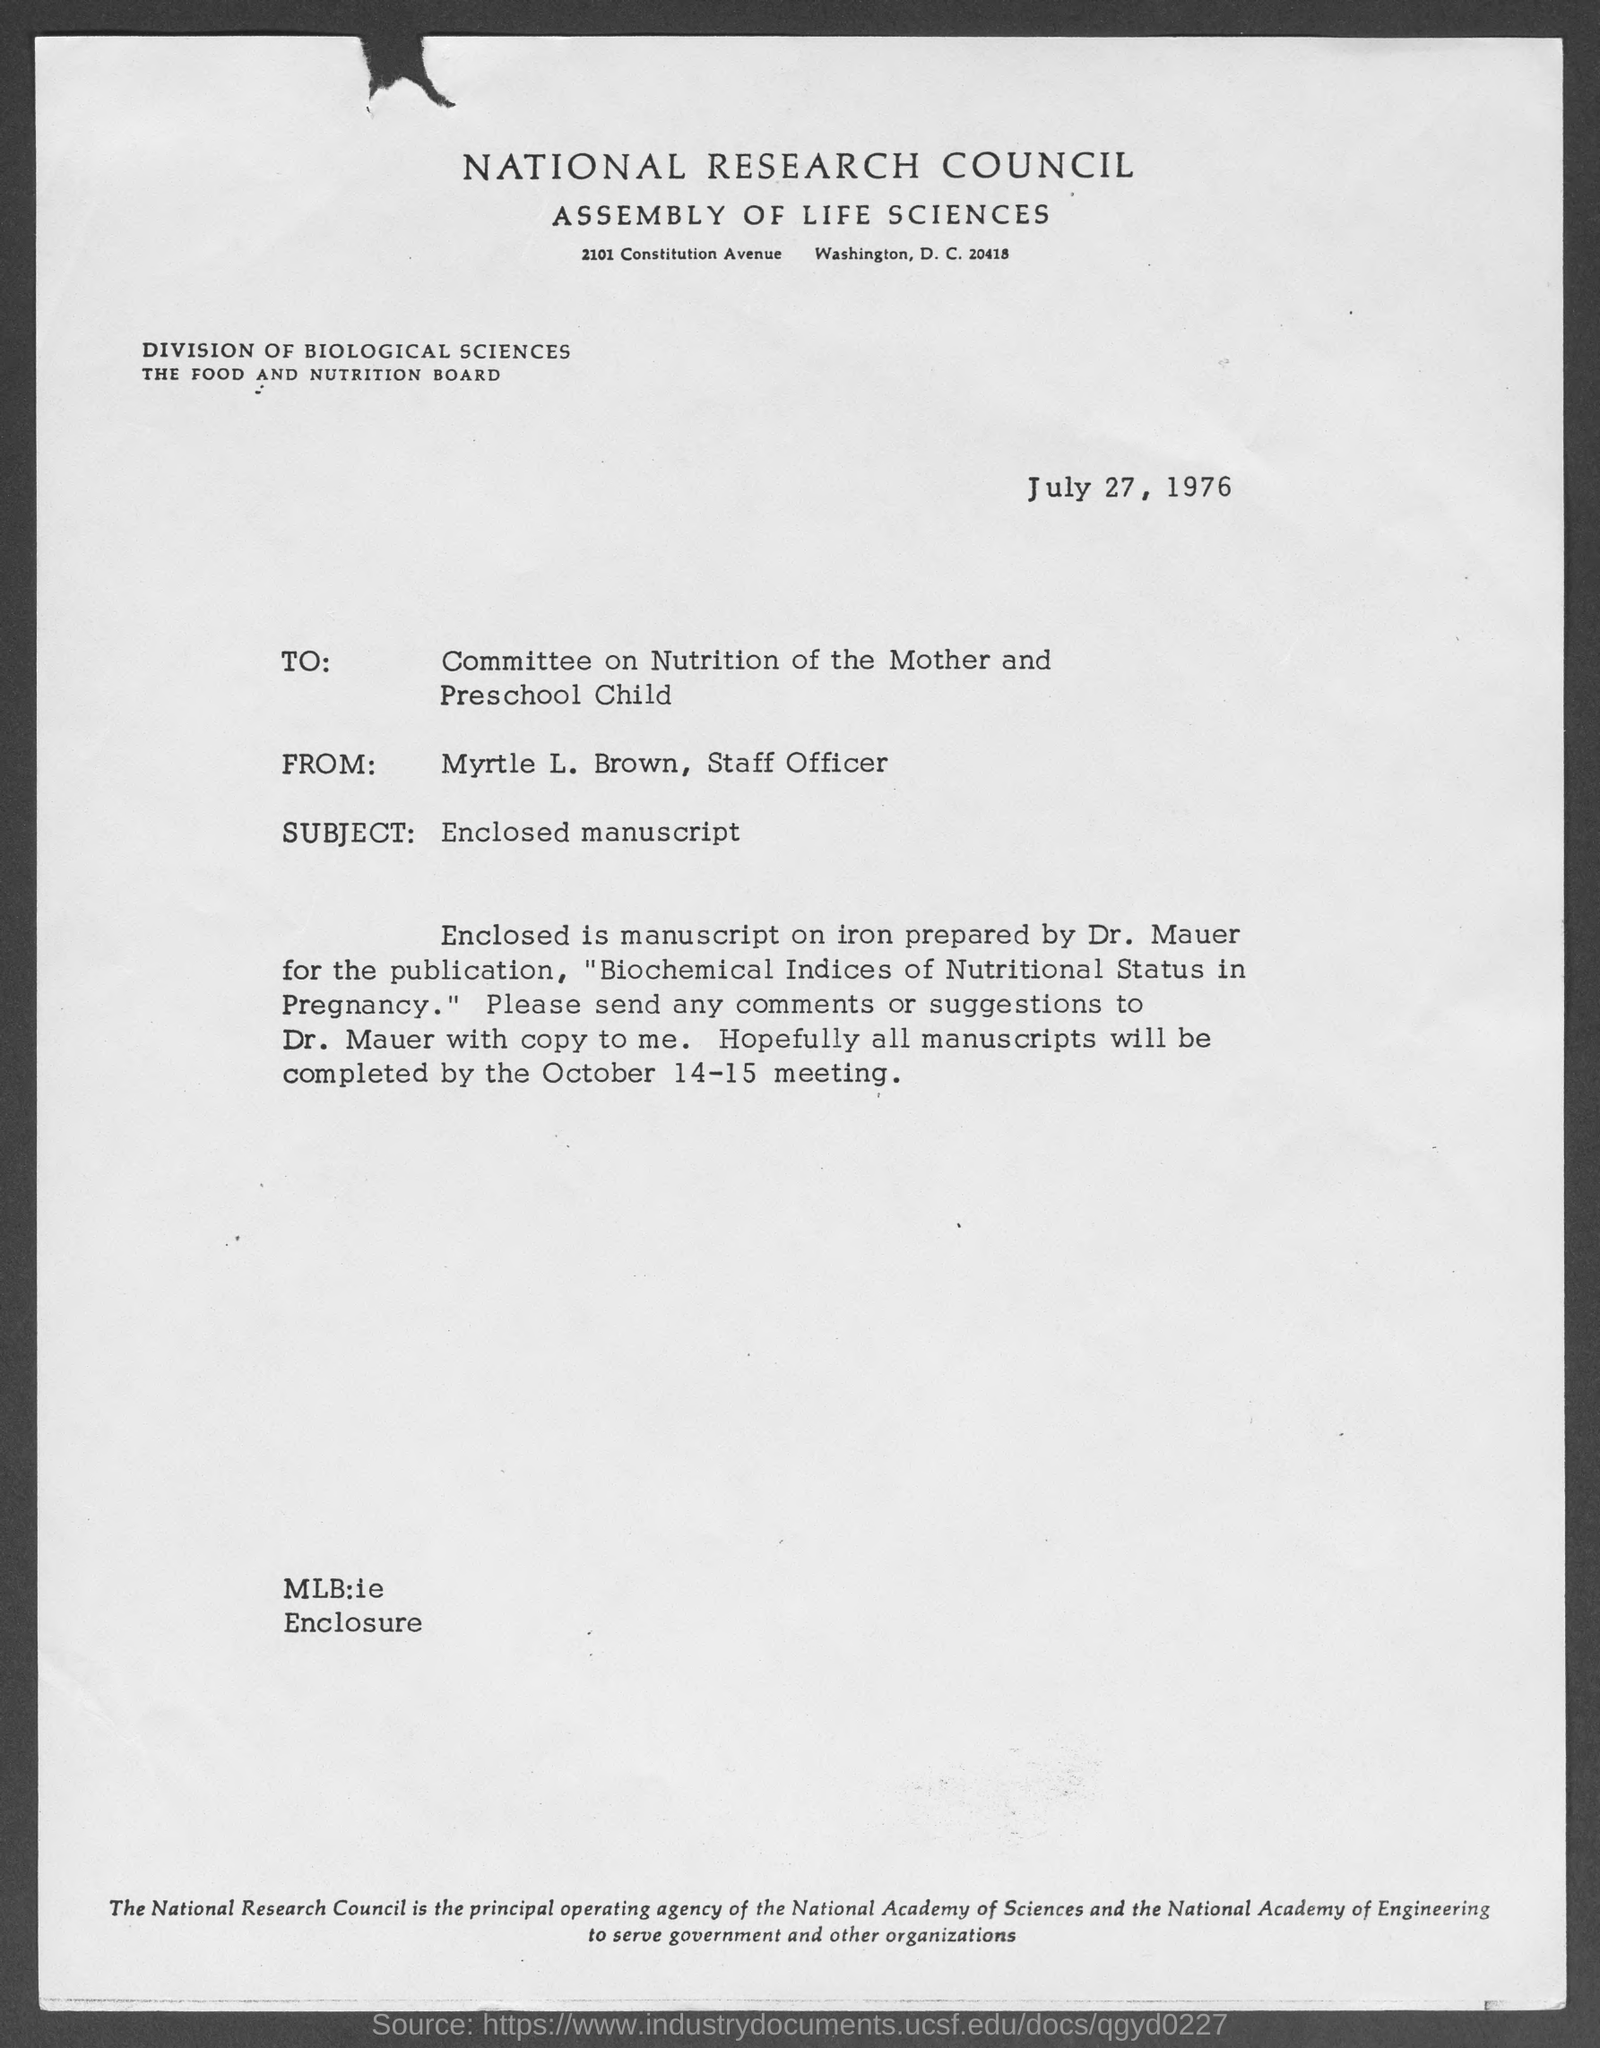Outline some significant characteristics in this image. Myrtle L. Brown is a Staff Officer. The National Research Council Assembly of Life Sciences has a street address of 2101 Constitution Avenue in Washington, D.C. The address is 20418. The memorandum is dated July 27, 1976. The subject of the memorandum is an enclosed manuscript. 